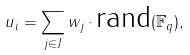<formula> <loc_0><loc_0><loc_500><loc_500>u _ { i } = \sum _ { j \in J } w _ { j } \cdot \text {rand} ( \mathbb { F } _ { q } ) ,</formula> 